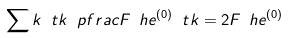Convert formula to latex. <formula><loc_0><loc_0><loc_500><loc_500>\sum k \ t k \ p f r a c { F _ { \ } h e ^ { ( 0 ) } } { \ t k } = 2 F _ { \ } h e ^ { ( 0 ) }</formula> 